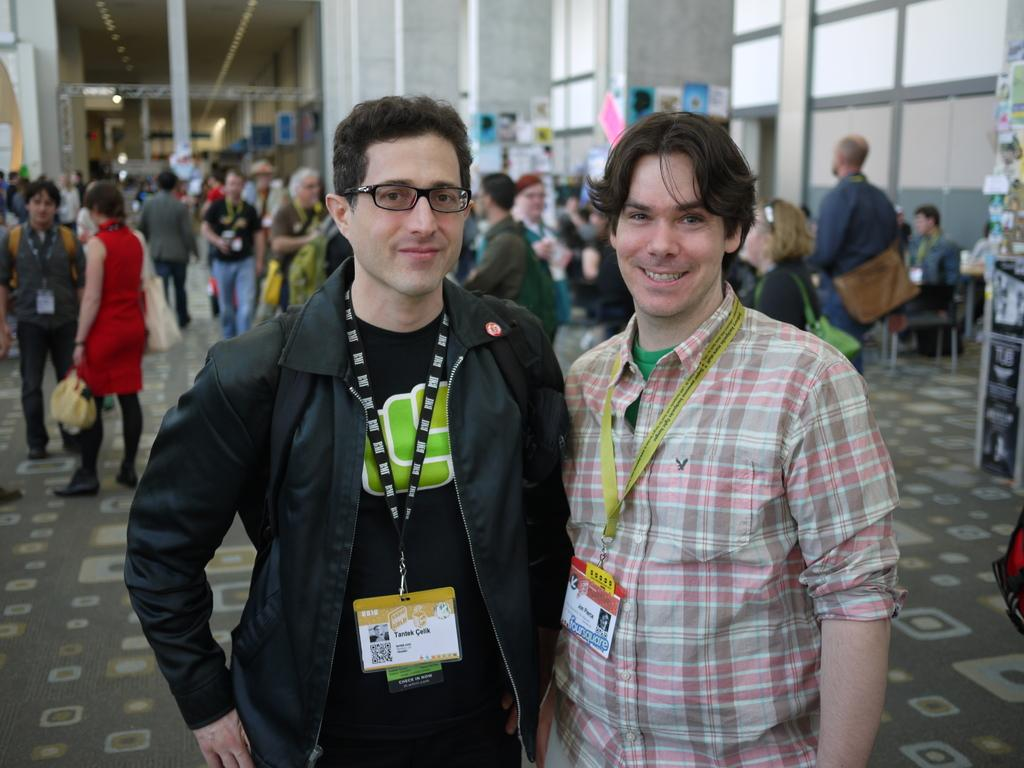What is happening with the people in the image? There are people standing on the floor in the image. What can be seen attached to a pillar in the image? There are posts attached to a pillar in the image. What is located on the right side of the image? There is a board on the right side of the image. What degree does the book on the board have in the image? There is no book present in the image, so it is not possible to determine the degree of a book. 